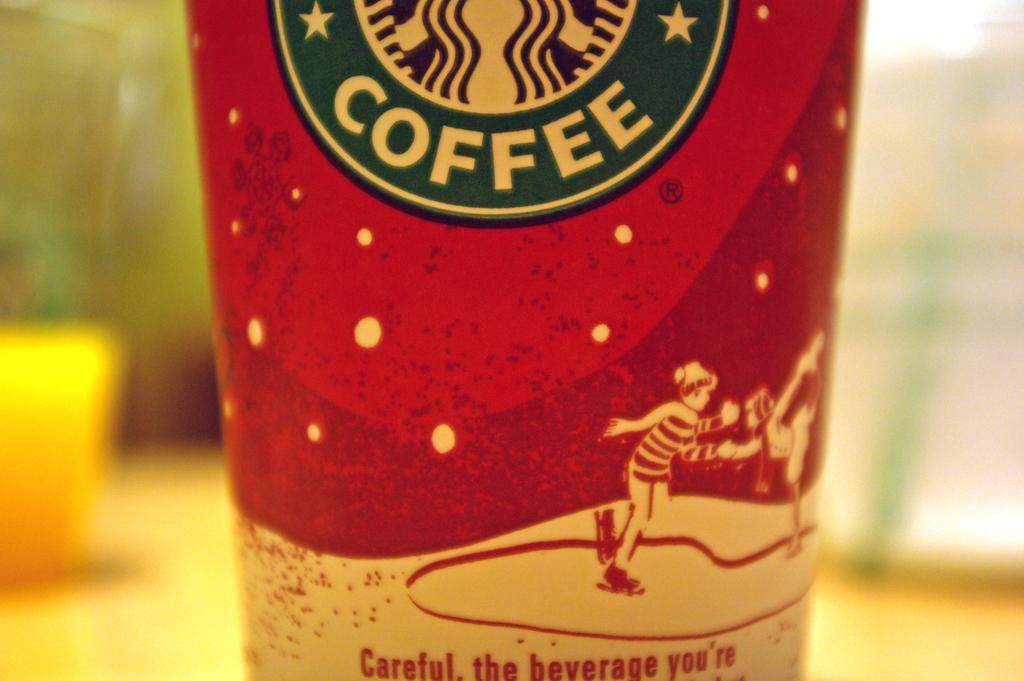<image>
Render a clear and concise summary of the photo. A coffee cup has a warning that begins "Careful, the beverage you're." 